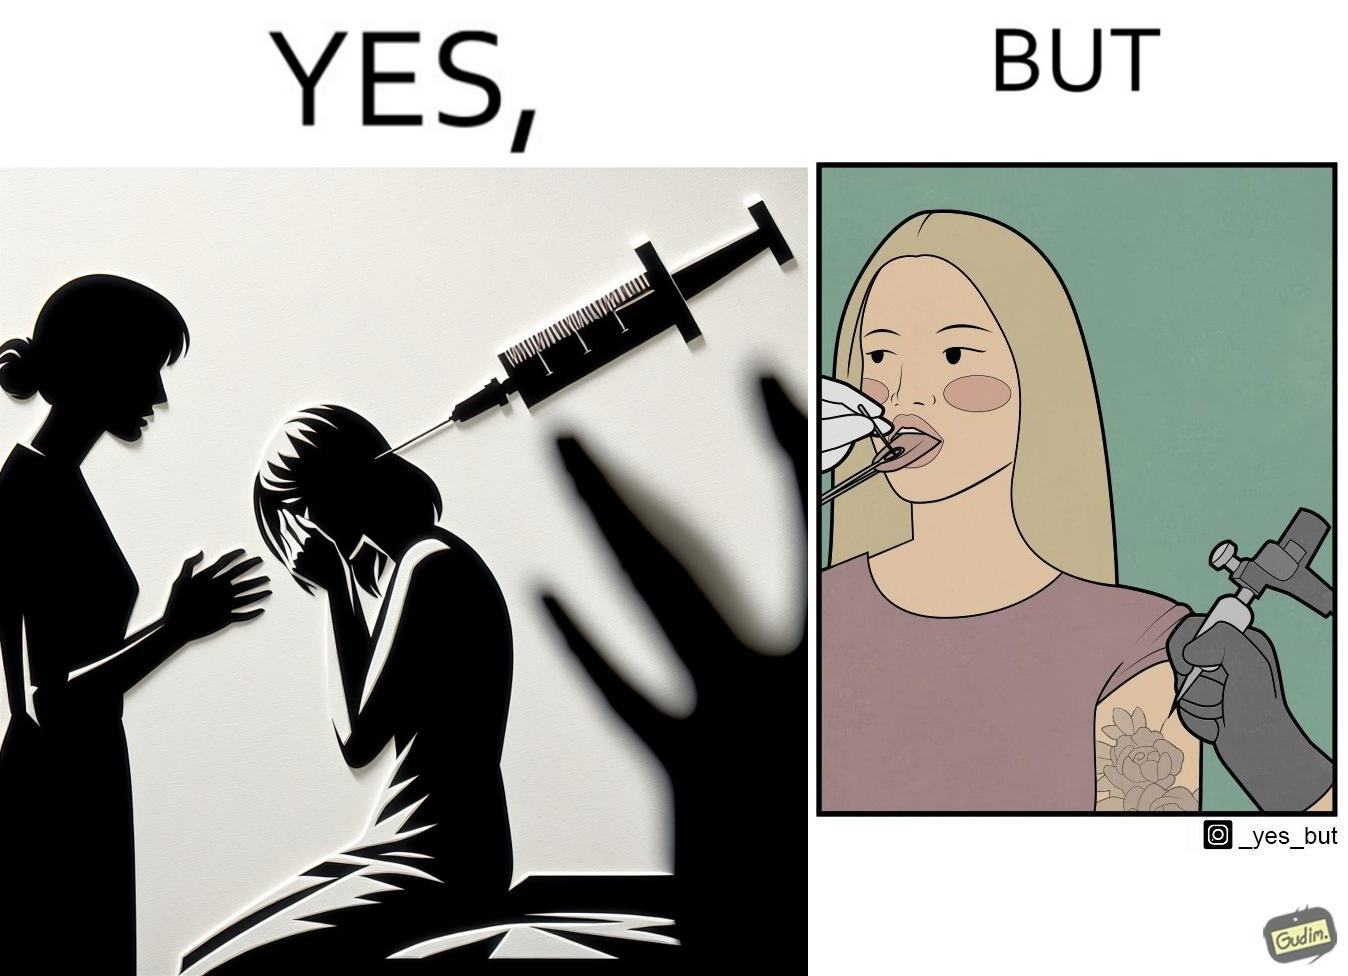Does this image contain satire or humor? Yes, this image is satirical. 